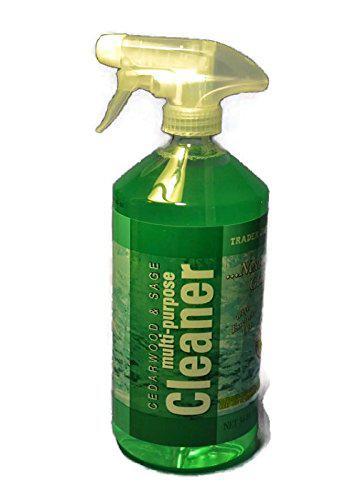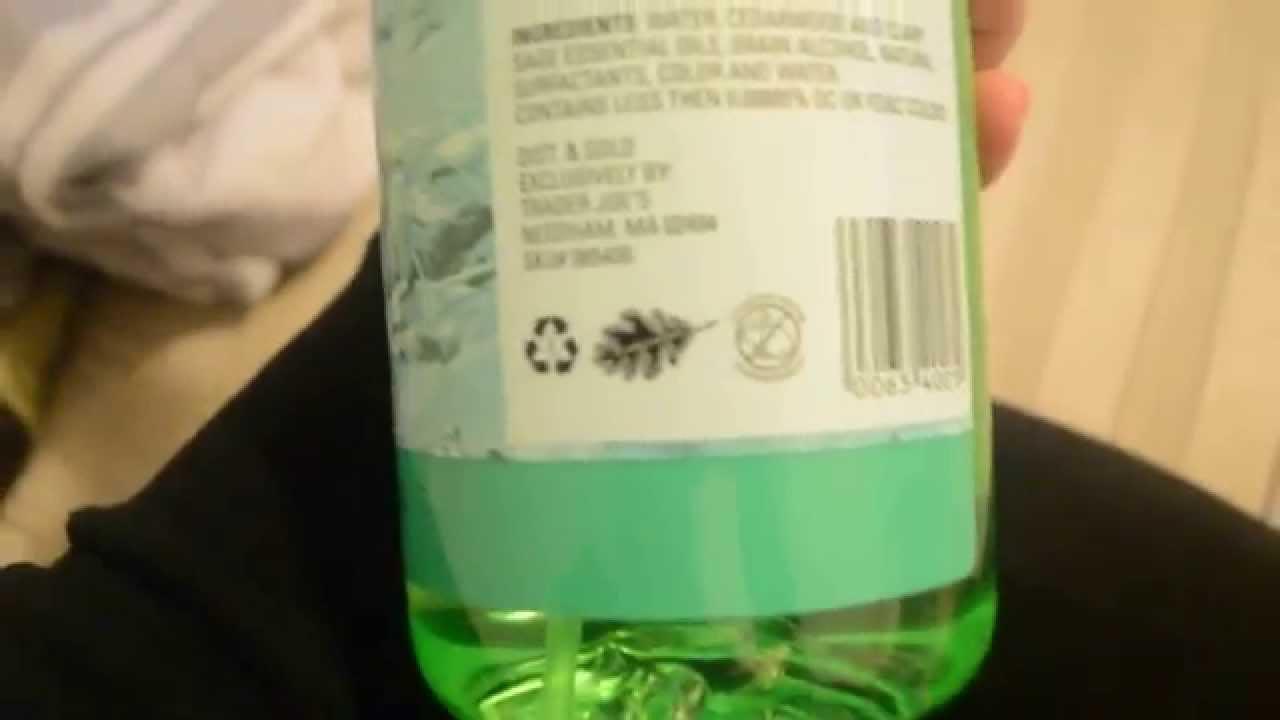The first image is the image on the left, the second image is the image on the right. For the images shown, is this caption "There is at least one spray bottle that contains multi purpose cleaner." true? Answer yes or no. Yes. The first image is the image on the left, the second image is the image on the right. Analyze the images presented: Is the assertion "There is a bottle with a squeeze trigger in the image on the right" valid? Answer yes or no. Yes. 